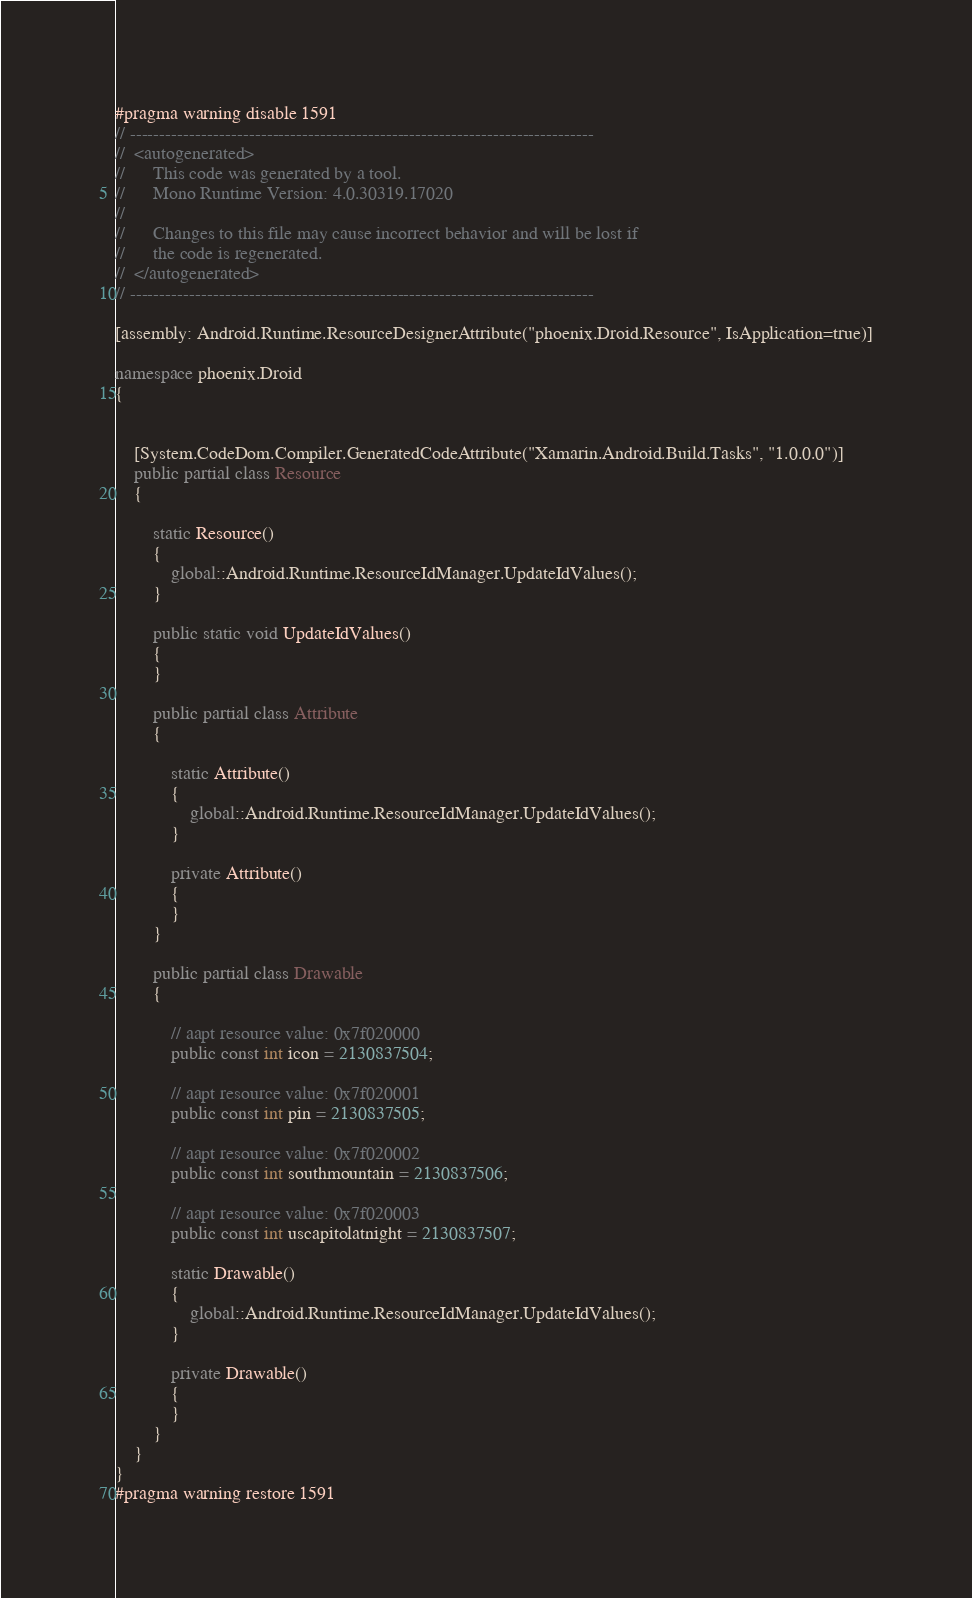<code> <loc_0><loc_0><loc_500><loc_500><_C#_>#pragma warning disable 1591
// ------------------------------------------------------------------------------
//  <autogenerated>
//      This code was generated by a tool.
//      Mono Runtime Version: 4.0.30319.17020
// 
//      Changes to this file may cause incorrect behavior and will be lost if 
//      the code is regenerated.
//  </autogenerated>
// ------------------------------------------------------------------------------

[assembly: Android.Runtime.ResourceDesignerAttribute("phoenix.Droid.Resource", IsApplication=true)]

namespace phoenix.Droid
{
	
	
	[System.CodeDom.Compiler.GeneratedCodeAttribute("Xamarin.Android.Build.Tasks", "1.0.0.0")]
	public partial class Resource
	{
		
		static Resource()
		{
			global::Android.Runtime.ResourceIdManager.UpdateIdValues();
		}
		
		public static void UpdateIdValues()
		{
		}
		
		public partial class Attribute
		{
			
			static Attribute()
			{
				global::Android.Runtime.ResourceIdManager.UpdateIdValues();
			}
			
			private Attribute()
			{
			}
		}
		
		public partial class Drawable
		{
			
			// aapt resource value: 0x7f020000
			public const int icon = 2130837504;
			
			// aapt resource value: 0x7f020001
			public const int pin = 2130837505;
			
			// aapt resource value: 0x7f020002
			public const int southmountain = 2130837506;
			
			// aapt resource value: 0x7f020003
			public const int uscapitolatnight = 2130837507;
			
			static Drawable()
			{
				global::Android.Runtime.ResourceIdManager.UpdateIdValues();
			}
			
			private Drawable()
			{
			}
		}
	}
}
#pragma warning restore 1591
</code> 